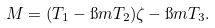Convert formula to latex. <formula><loc_0><loc_0><loc_500><loc_500>M = ( T _ { 1 } - \i m T _ { 2 } ) \zeta - \i m T _ { 3 } .</formula> 